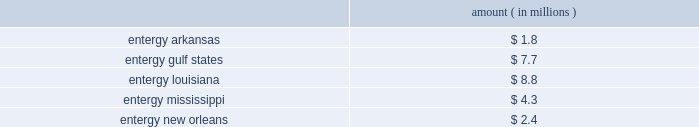Domestic utility companies and system energy notes to respective financial statements protested the disallowance of these deductions to the office of irs appeals .
Entergy expects to receive a notice of deficiency in 2005 for this item , and plans to vigorously contest this matter .
Entergy believes that the contingency provision established in its financial statements sufficiently covers the risk associated with this item .
Mark to market of certain power contracts in 2001 , entergy louisiana changed its method of accounting for tax purposes related to its wholesale electric power contracts .
The most significant of these is the contract to purchase power from the vidalia hydroelectric project .
The new tax accounting method has provided a cumulative cash flow benefit of approximately $ 790 million as of december 31 , 2004 .
The related irs interest exposure is $ 93 million at december 31 , 2004 .
This benefit is expected to reverse in the years 2005 through 2031 .
The election did not reduce book income tax expense .
The timing of the reversal of this benefit depends on several variables , including the price of power .
Due to the temporary nature of the tax benefit , the potential interest charge represents entergy's net earnings exposure .
Entergy louisiana's 2001 tax return is currently under examination by the irs , though no adjustments have yet been proposed with respect to the mark to market election .
Entergy believes that the contingency provision established in its financial statements will sufficiently cover the risk associated with this issue .
Cashpoint bankruptcy ( entergy arkansas , entergy gulf states , entergy louisiana , entergy mississippi , and entergy new orleans ) in 2003 the domestic utility companies entered an agreement with cashpoint network services ( cashpoint ) under which cashpoint was to manage a network of payment agents through which entergy's utility customers could pay their bills .
The payment agent system allows customers to pay their bills at various commercial or governmental locations , rather than sending payments by mail .
Approximately one-third of entergy's utility customers use payment agents .
On april 19 , 2004 , cashpoint failed to pay funds due to the domestic utility companies that had been collected through payment agents .
The domestic utility companies then obtained a temporary restraining order from the civil district court for the parish of orleans , state of louisiana , enjoining cashpoint from distributing funds belonging to entergy , except by paying those funds to entergy .
On april 22 , 2004 , a petition for involuntary chapter 7 bankruptcy was filed against cashpoint by other creditors in the united states bankruptcy court for the southern district of new york .
In response to these events , the domestic utility companies expanded an existing contract with another company to manage all of their payment agents .
The domestic utility companies filed proofs of claim in the cashpoint bankruptcy proceeding in september 2004 .
Although entergy cannot precisely determine at this time the amount that cashpoint owes to the domestic utility companies that may not be repaid , it has accrued an estimate of loss based on current information .
If no cash is repaid to the domestic utility companies , an event entergy does not believe is likely , the current estimates of maximum exposure to loss are approximately as follows : amount ( in millions ) .
Environmental issues ( entergy gulf states ) entergy gulf states has been designated as a prp for the cleanup of certain hazardous waste disposal sites .
As of december 31 , 2004 , entergy gulf states does not expect the remaining clean-up costs to exceed its recorded liability of $ 1.5 million for the remaining sites at which the epa has designated entergy gulf states as a prp. .
What is the maximum exposure to loss for entergy if no cash is repaid to domestic utility companies , in millions? 
Computations: ((((1.8 + 7.7) + 8.8) + 4.3) + 2.4)
Answer: 25.0. 